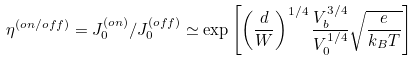<formula> <loc_0><loc_0><loc_500><loc_500>\eta ^ { ( o n / o f f ) } = J _ { 0 } ^ { ( o n ) } / J _ { 0 } ^ { ( o f f ) } \simeq \exp \left [ \left ( \frac { d } { W } \right ) ^ { 1 / 4 } \frac { V _ { b } ^ { 3 / 4 } } { V _ { 0 } ^ { 1 / 4 } } \sqrt { \frac { e } { k _ { B } T } } \right ]</formula> 